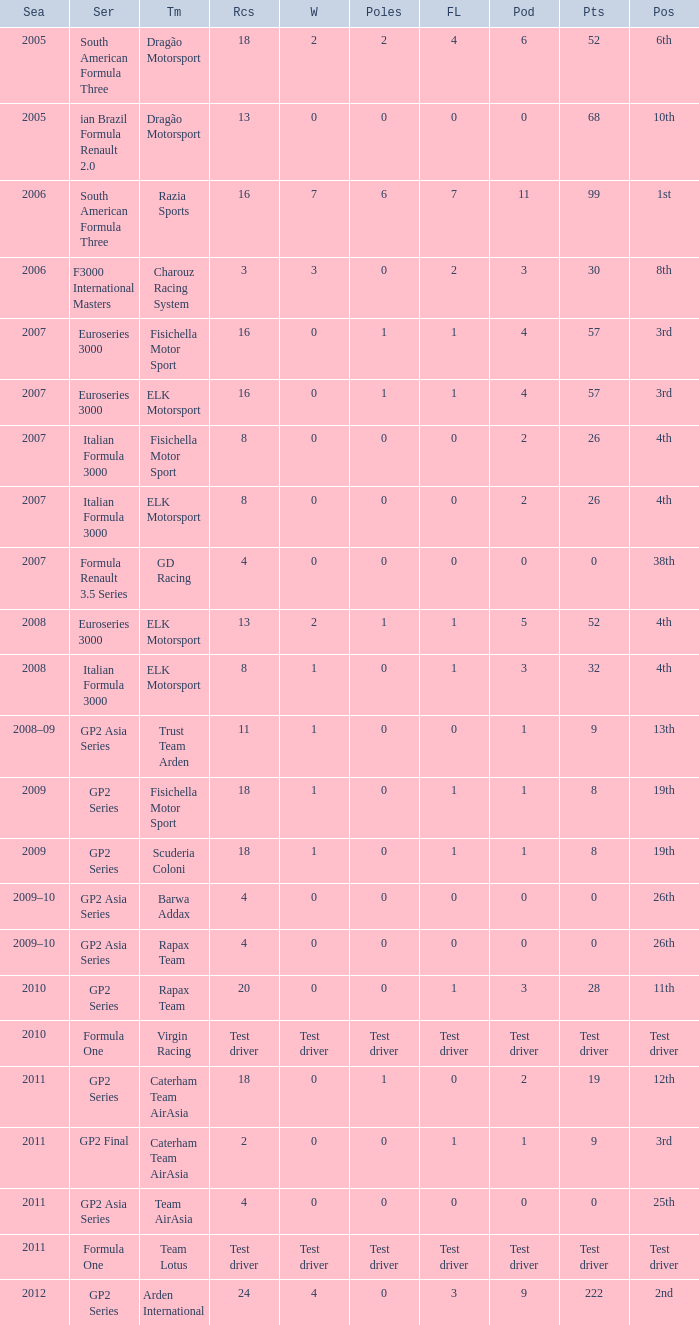What were the points in the year when his Podiums were 5? 52.0. 